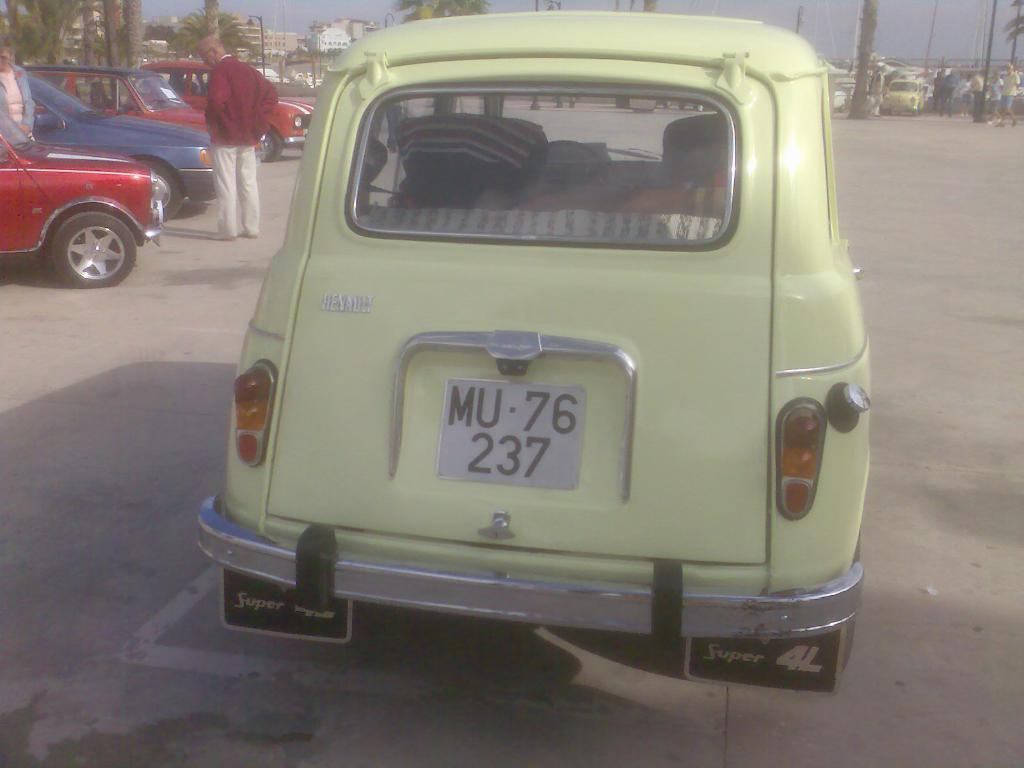What is the main subject in the foreground of the image? There is a vehicle on the road in the image. What can be seen in the background of the image? There are vehicles, people, trees, poles, objects, buildings, and the sky visible in the background of the image. How many slaves are visible in the image? There are no slaves present in the image. What type of bubble can be seen in the image? There are no bubbles present in the image. 